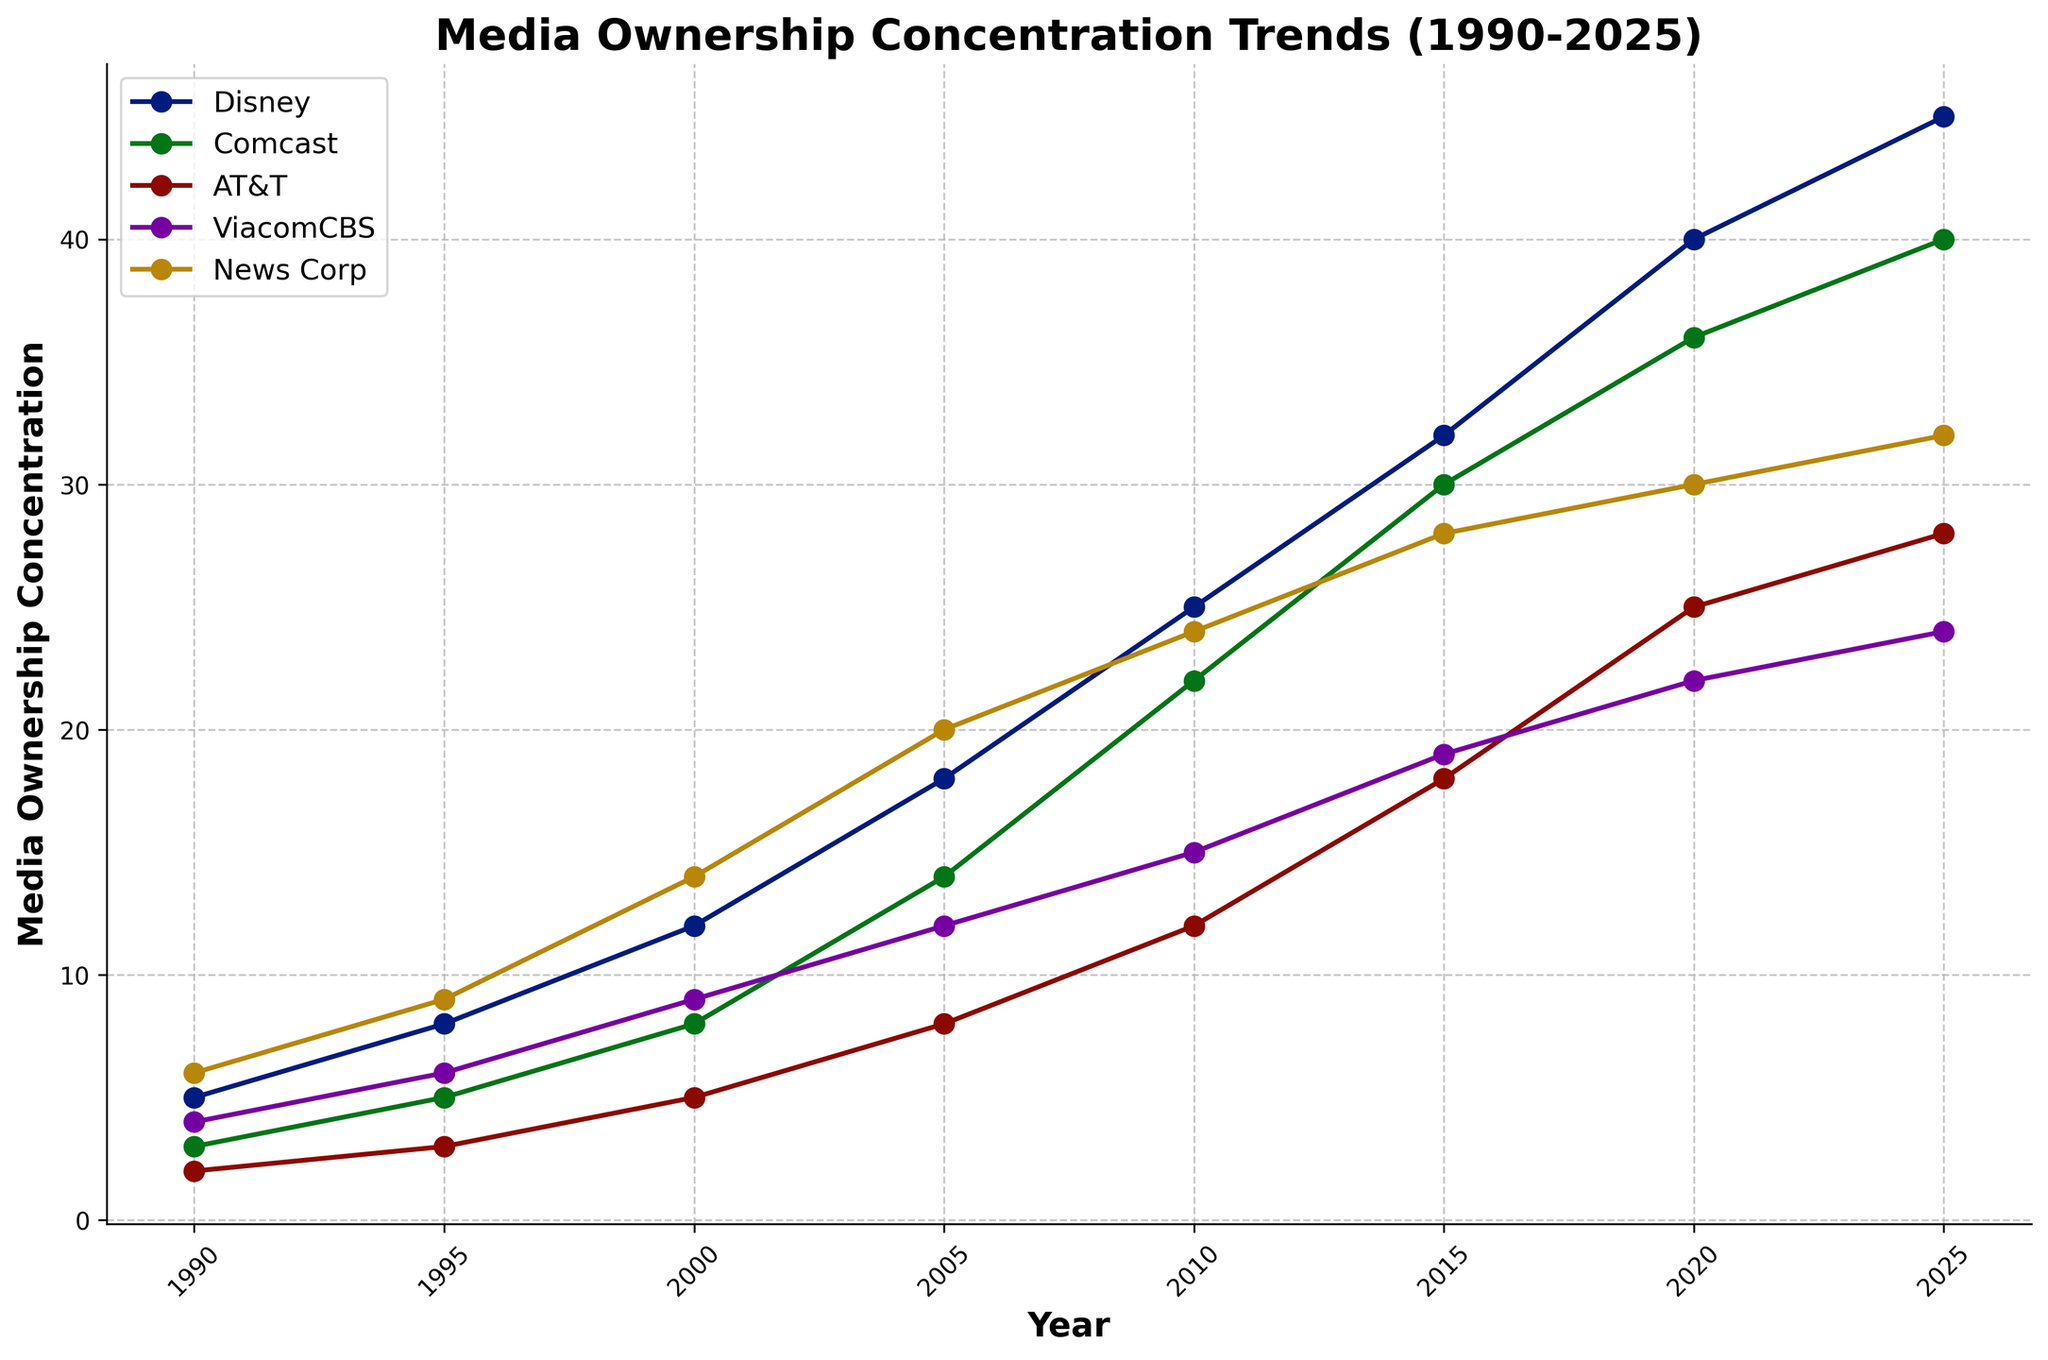What's the trend of Disney's media ownership concentration from 1990 to 2025? By observing the line representing Disney, we see it starts at 5 in 1990 and gradually increases to 45 in 2025, indicating a steadily increasing trend.
Answer: Steadily increasing Which company had the highest media ownership concentration in 2000? The highest point in 2000 on the graph corresponds to News Corp, at a value of 14.
Answer: News Corp How does Comcast's media ownership concentration change between 1995 and 2020? Comcast's concentration increases from 5 in 1995 to 36 in 2020, showing a rising trend over the years.
Answer: Rising trend Compare the media ownership concentration of AT&T and ViacomCBS in 2010. In 2010, AT&T has a concentration of 12, while ViacomCBS has 15, making ViacomCBS's concentration higher.
Answer: ViacomCBS is higher What is the average concentration of News Corp's media ownership over the entire period? Sum the values of News Corp from each year (6 + 9 + 14 + 20 + 24 + 28 + 30 + 32 = 163) and divide by the number of years (163/8).
Answer: 20.375 Between 2015 and 2020, which company had the largest increase in media ownership concentration? Calculate the difference: Disney (40-32=8), Comcast (36-30=6), AT&T (25-18=7), ViacomCBS (22-19=3), News Corp (30-28=2). Disney had the largest increase of 8.
Answer: Disney Which company had the smallest growth in media ownership between 2000 and 2025? Calculate the growth: Disney (45-12=33), Comcast (40-8=32), AT&T (28-5=23), ViacomCBS (24-9=15), News Corp (32-14=18). ViacomCBS had the smallest growth of 15.
Answer: ViacomCBS Was there any year where two or more companies had the same media ownership concentration? Observing the graph, there does not appear to be any year where the lines for the companies intersect at the same concentration value.
Answer: No What is the difference in media ownership concentration between the highest and lowest companies in 2025? In 2025, the highest concentration is Disney (45) and the lowest is AT&T (28). Difference = 45 - 28.
Answer: 17 